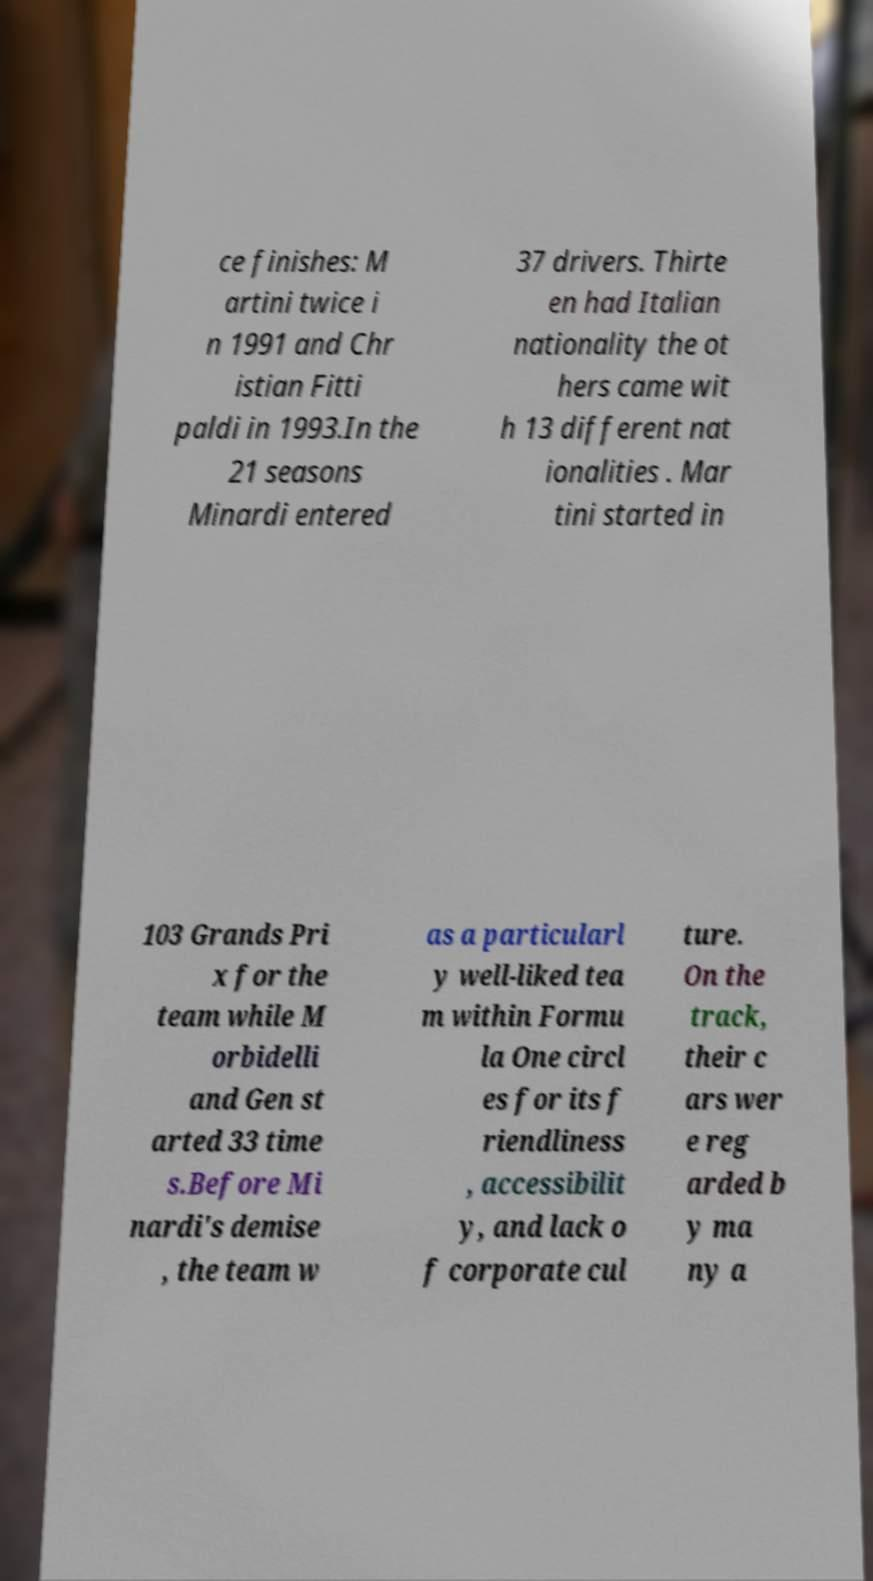Could you extract and type out the text from this image? ce finishes: M artini twice i n 1991 and Chr istian Fitti paldi in 1993.In the 21 seasons Minardi entered 37 drivers. Thirte en had Italian nationality the ot hers came wit h 13 different nat ionalities . Mar tini started in 103 Grands Pri x for the team while M orbidelli and Gen st arted 33 time s.Before Mi nardi's demise , the team w as a particularl y well-liked tea m within Formu la One circl es for its f riendliness , accessibilit y, and lack o f corporate cul ture. On the track, their c ars wer e reg arded b y ma ny a 